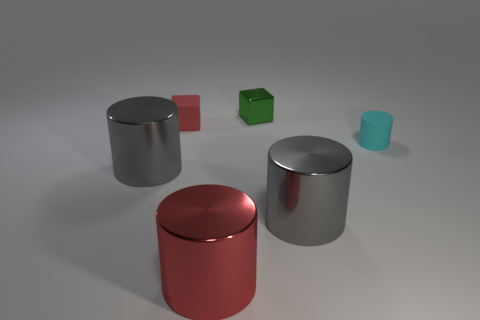Is the size of the matte cylinder the same as the red metal thing?
Give a very brief answer. No. What number of cylinders are either gray metal things or tiny cyan things?
Provide a short and direct response. 3. There is a large object that is the same color as the matte cube; what material is it?
Ensure brevity in your answer.  Metal. What number of other tiny green things are the same shape as the small shiny thing?
Offer a terse response. 0. Is the number of matte things that are left of the green metal block greater than the number of blocks in front of the large red shiny cylinder?
Offer a very short reply. Yes. There is a tiny rubber thing that is on the right side of the small green thing; is it the same color as the matte block?
Offer a very short reply. No. The rubber cube has what size?
Offer a very short reply. Small. What is the material of the other block that is the same size as the green block?
Provide a succinct answer. Rubber. What color is the rubber object that is behind the cyan rubber cylinder?
Ensure brevity in your answer.  Red. How many gray metallic cylinders are there?
Keep it short and to the point. 2. 